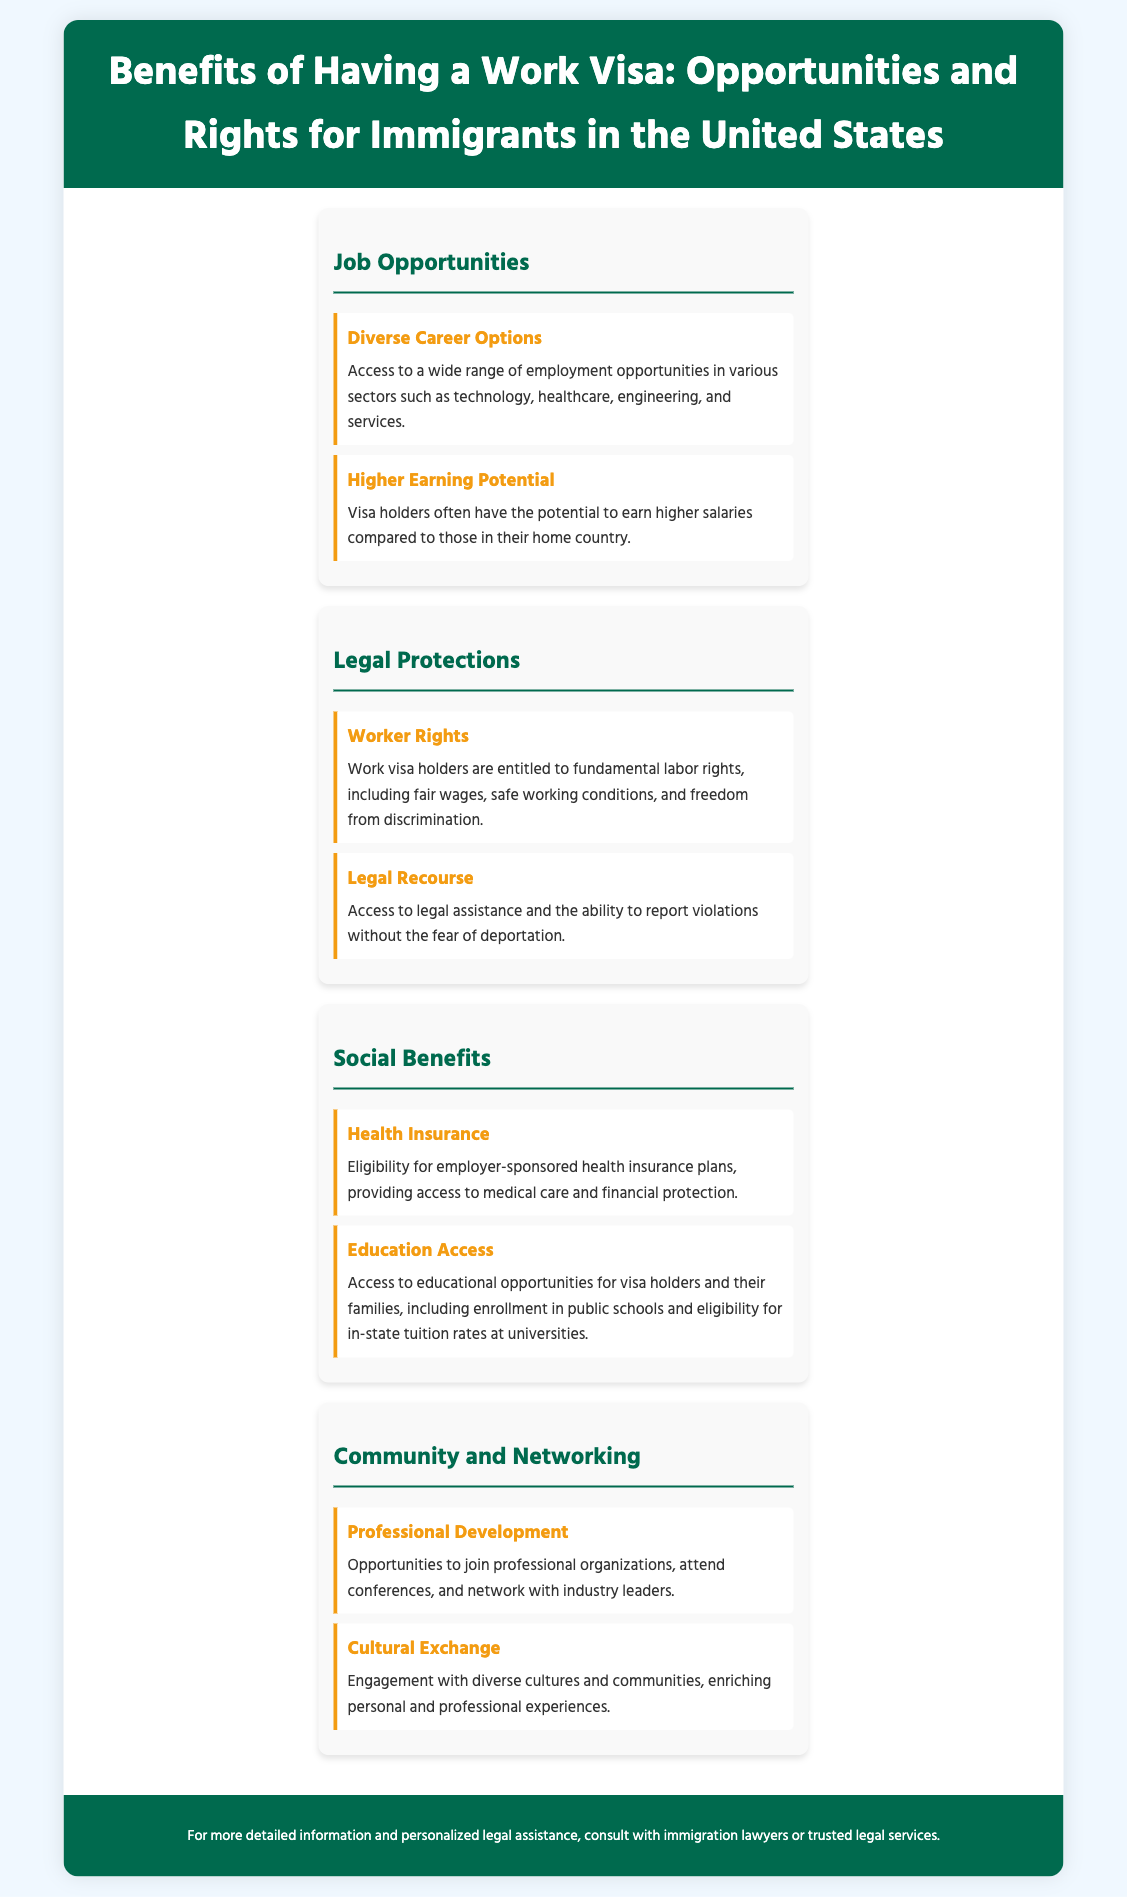What are the two main categories of benefits listed? The document highlights "Job Opportunities" and "Legal Protections" as the main categories of benefits.
Answer: Job Opportunities, Legal Protections What is one sector mentioned for diverse career options? The document states that visa holders have access to career options in various sectors, including technology, healthcare, engineering, and services.
Answer: Technology What legal protection is guaranteed to work visa holders? The document specifies fundamental labor rights, which include fair wages, safe working conditions, and freedom from discrimination.
Answer: Worker Rights What type of insurance can visa holders access? The content mentions eligibility for employer-sponsored health insurance plans, which provide access to medical care.
Answer: Health Insurance What opportunity is provided for professional development? The document explains that visa holders have opportunities to join professional organizations and attend conferences.
Answer: Join professional organizations What aspect of community is enriched by having a work visa? The document states that a work visa allows engagement with diverse cultures and communities, enhancing personal and professional experiences.
Answer: Cultural Exchange What benefits do the families of visa holders also receive? The document notes that families of visa holders have access to educational opportunities, including enrollment in public schools.
Answer: Educational opportunities How are work visa holders protected when facing violations? The document highlights that visa holders have access to legal assistance and can report violations without fear of deportation.
Answer: Legal Recourse 